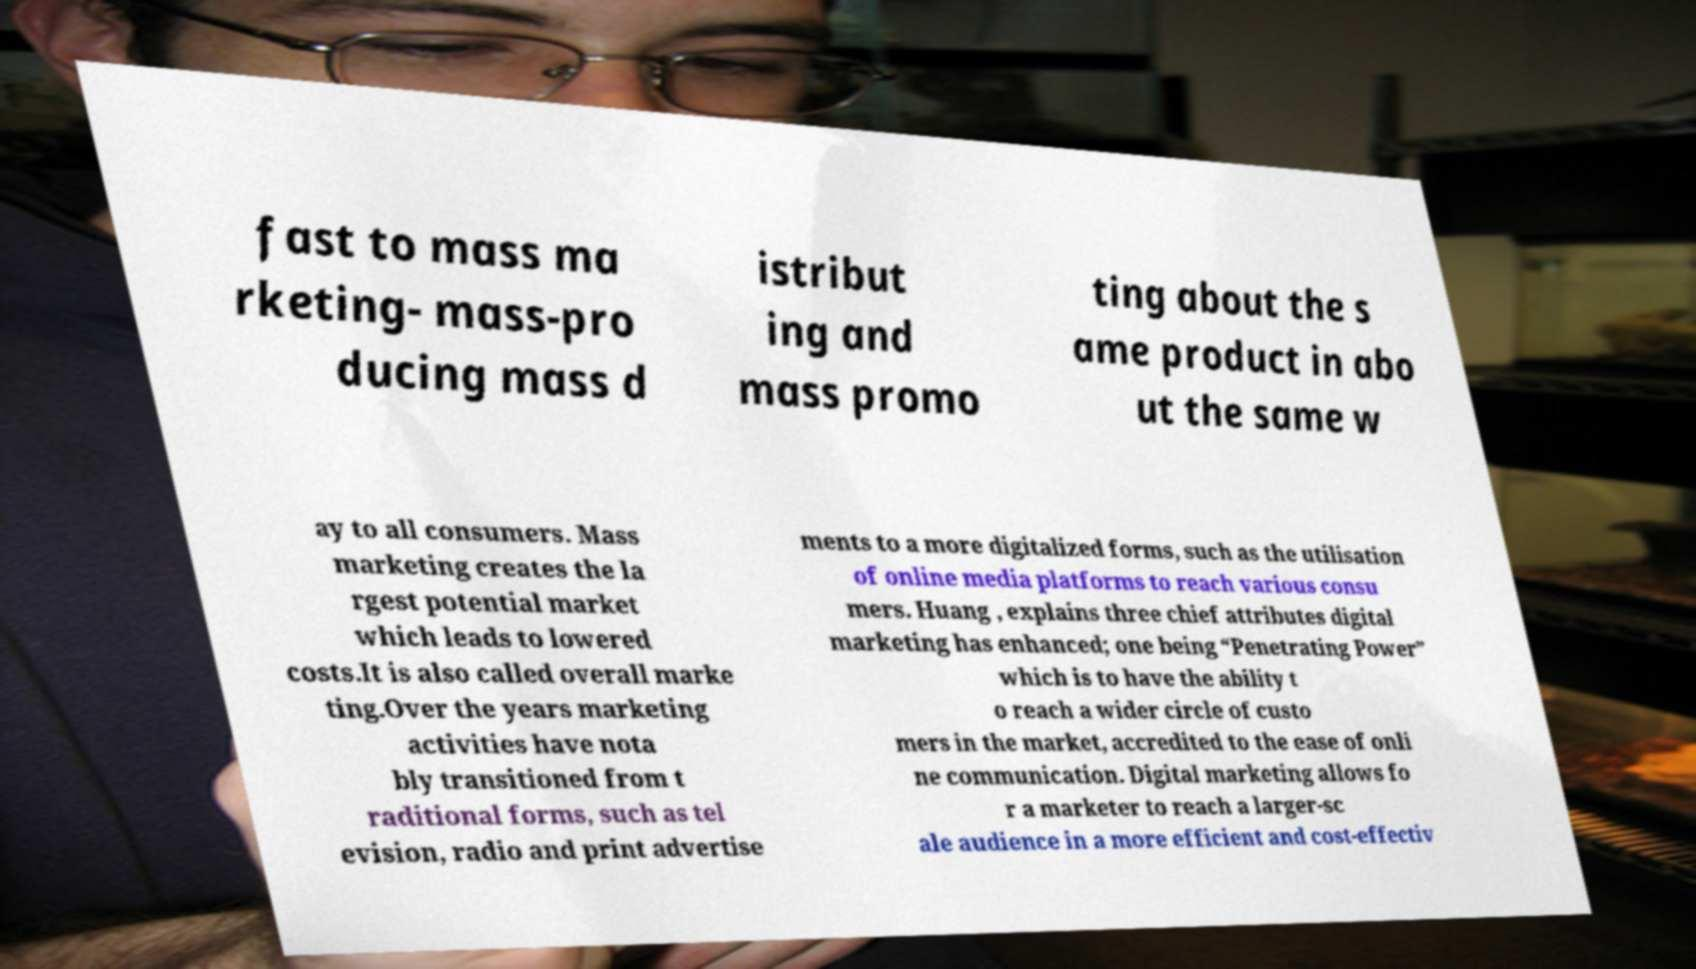Could you assist in decoding the text presented in this image and type it out clearly? fast to mass ma rketing- mass-pro ducing mass d istribut ing and mass promo ting about the s ame product in abo ut the same w ay to all consumers. Mass marketing creates the la rgest potential market which leads to lowered costs.It is also called overall marke ting.Over the years marketing activities have nota bly transitioned from t raditional forms, such as tel evision, radio and print advertise ments to a more digitalized forms, such as the utilisation of online media platforms to reach various consu mers. Huang , explains three chief attributes digital marketing has enhanced; one being “Penetrating Power” which is to have the ability t o reach a wider circle of custo mers in the market, accredited to the ease of onli ne communication. Digital marketing allows fo r a marketer to reach a larger-sc ale audience in a more efficient and cost-effectiv 